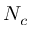Convert formula to latex. <formula><loc_0><loc_0><loc_500><loc_500>N _ { c }</formula> 